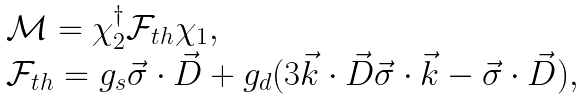<formula> <loc_0><loc_0><loc_500><loc_500>\begin{array} { l l } & { \mathcal { M } } = { \chi } _ { 2 } ^ { \dagger } { \mathcal { F } } _ { t h } { \chi } _ { 1 } , \\ & { \mathcal { F } } _ { t h } = g _ { s } \vec { \sigma } \cdot \vec { D } + g _ { d } ( 3 \vec { k } \cdot \vec { D } \vec { \sigma } \cdot \vec { k } - \vec { \sigma } \cdot \vec { D } ) , \end{array}</formula> 